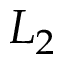<formula> <loc_0><loc_0><loc_500><loc_500>L _ { 2 }</formula> 